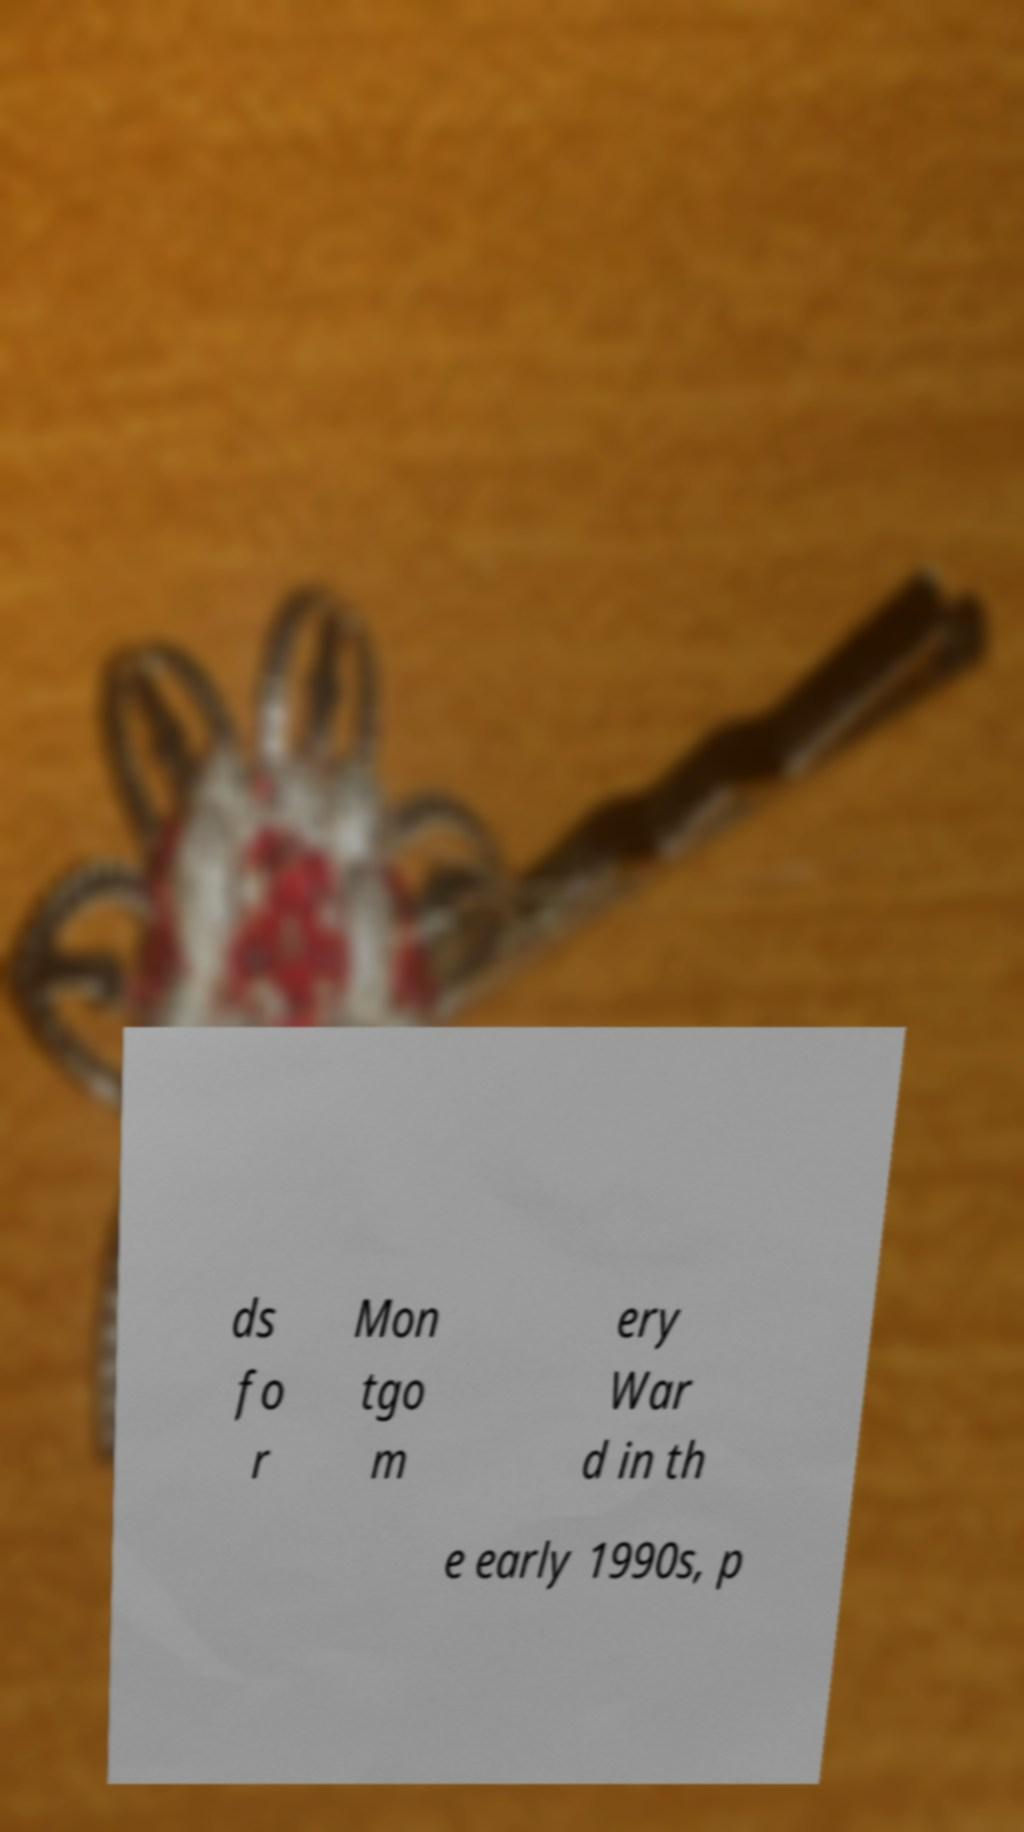There's text embedded in this image that I need extracted. Can you transcribe it verbatim? ds fo r Mon tgo m ery War d in th e early 1990s, p 